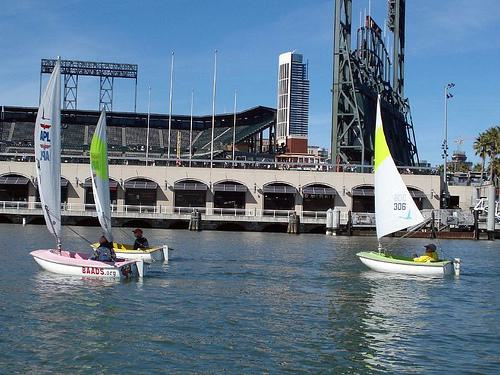Is there a boat in the image? Yes, there are two small sailboats in the foreground of the image, sailing on calm waters. Each boat has a crew of two and sport distinct, brightly colored sails—one with a vibrant yellow and the other sail is green with graphical patterns. 